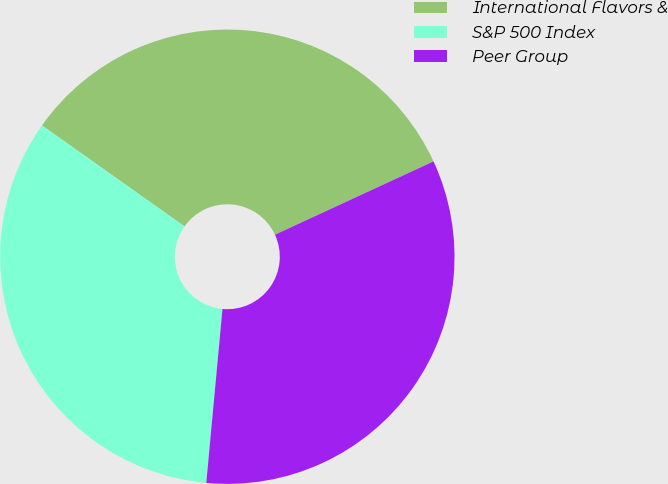<chart> <loc_0><loc_0><loc_500><loc_500><pie_chart><fcel>International Flavors &<fcel>S&P 500 Index<fcel>Peer Group<nl><fcel>33.3%<fcel>33.33%<fcel>33.37%<nl></chart> 